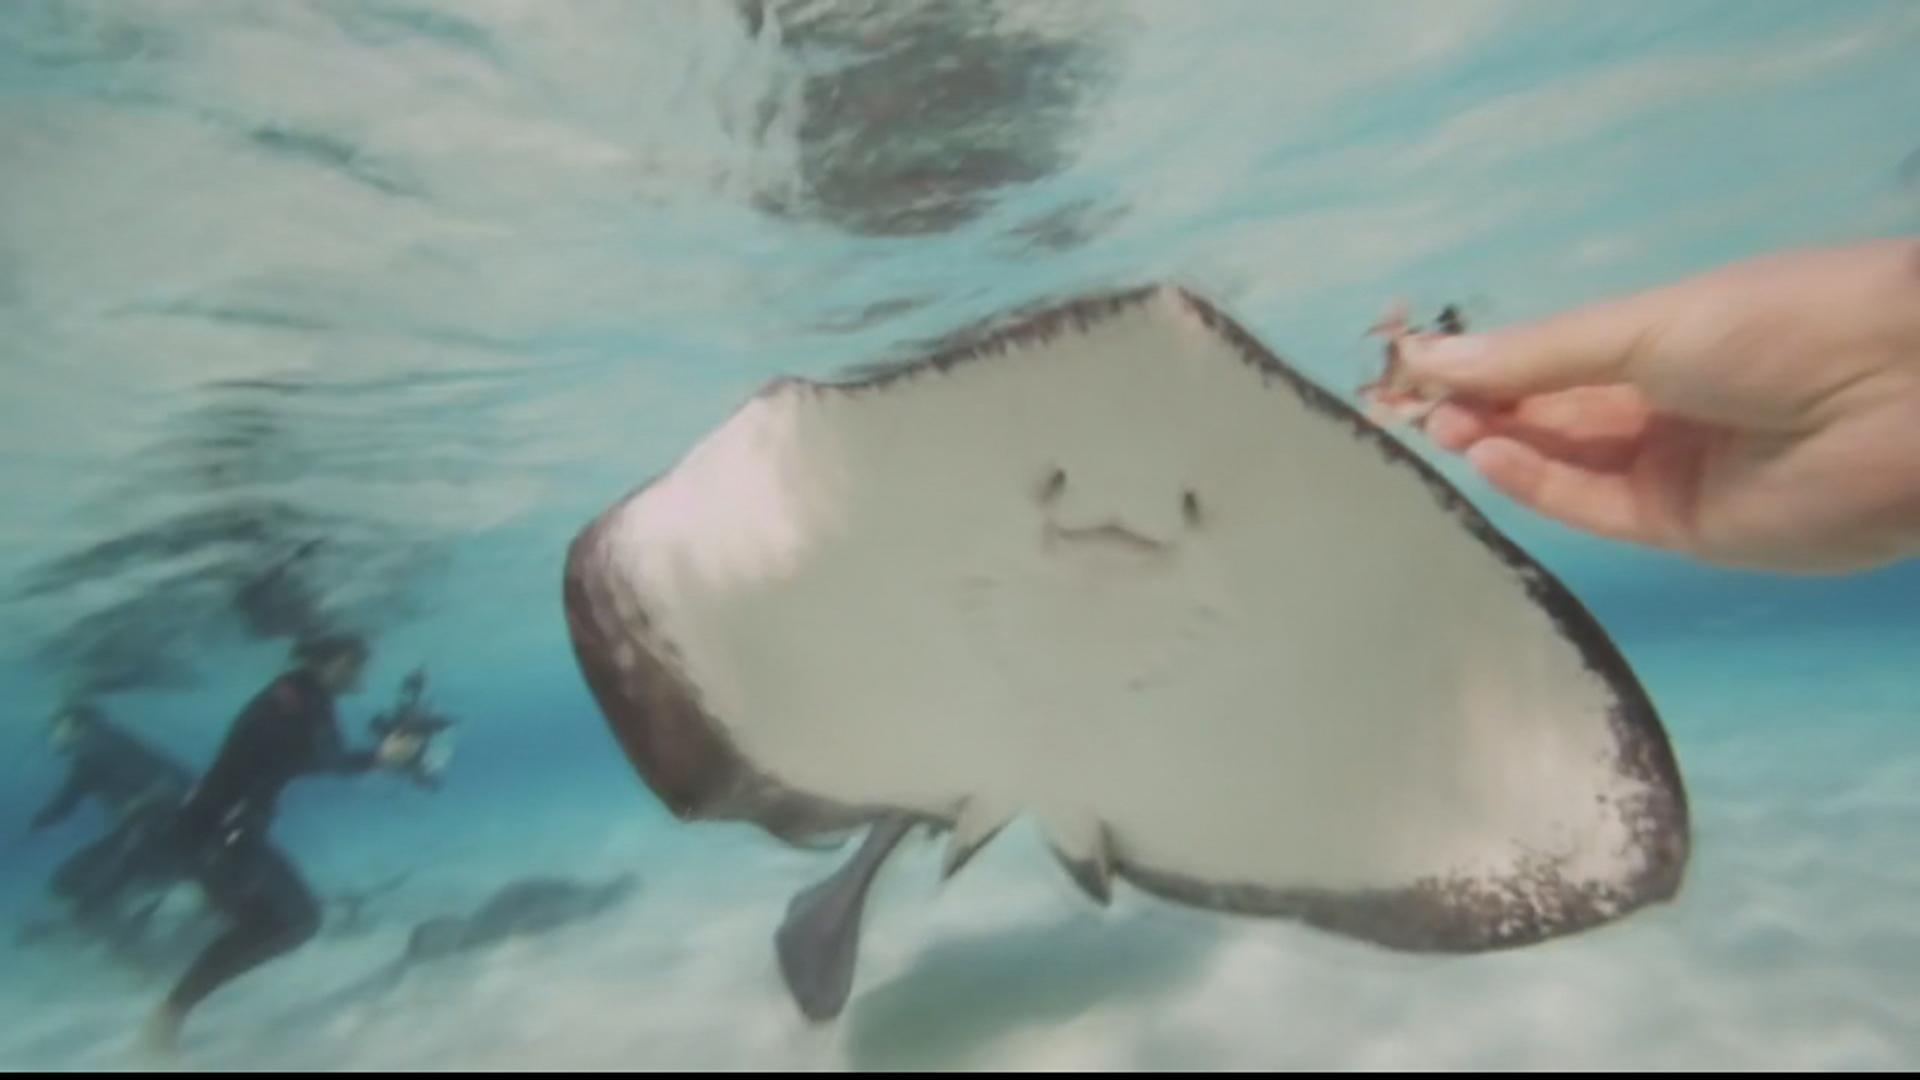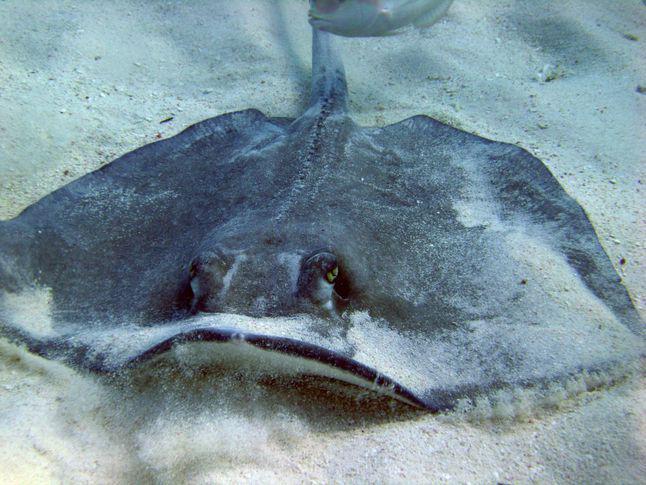The first image is the image on the left, the second image is the image on the right. Examine the images to the left and right. Is the description "One stingray with its underside facing the camera is in the foreground of an image." accurate? Answer yes or no. Yes. The first image is the image on the left, the second image is the image on the right. Examine the images to the left and right. Is the description "The underside of one of the rays in the water is visible in one of the images." accurate? Answer yes or no. Yes. 